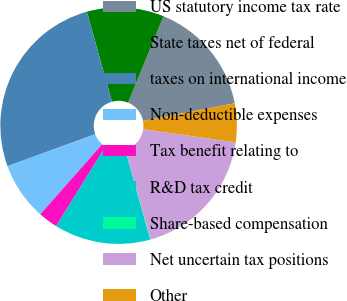Convert chart to OTSL. <chart><loc_0><loc_0><loc_500><loc_500><pie_chart><fcel>US statutory income tax rate<fcel>State taxes net of federal<fcel>taxes on international income<fcel>Non-deductible expenses<fcel>Tax benefit relating to<fcel>R&D tax credit<fcel>Share-based compensation<fcel>Net uncertain tax positions<fcel>Other<nl><fcel>15.77%<fcel>10.53%<fcel>26.25%<fcel>7.91%<fcel>2.67%<fcel>13.15%<fcel>0.05%<fcel>18.39%<fcel>5.29%<nl></chart> 